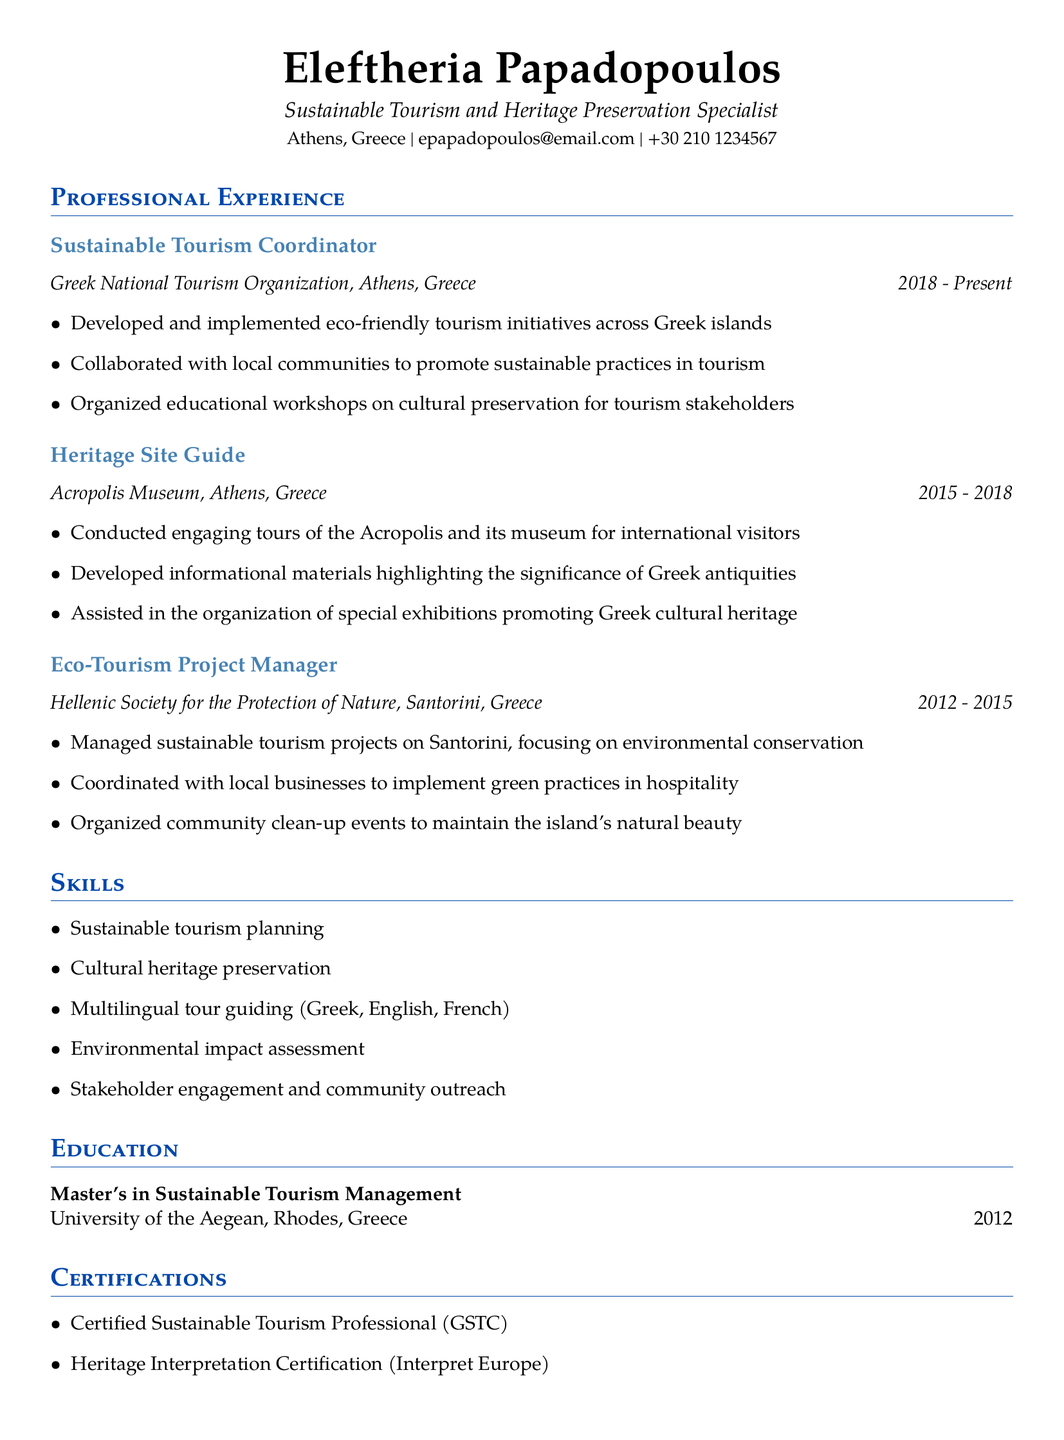what is the current position held by Eleftheria Papadopoulos? The document states that Eleftheria Papadopoulos is currently a Sustainable Tourism Coordinator.
Answer: Sustainable Tourism Coordinator what is the duration of Eleftheria's role at the Greek National Tourism Organization? The duration is specified as starting in 2018 and continuing to the present.
Answer: 2018 - Present how many languages can Eleftheria guide in? The document indicates that Eleftheria can guide in multiple languages, specifically mentioning three.
Answer: 3 what is the highest degree obtained by Eleftheria Papadopoulos? The document mentions that Eleftheria has a Master's in Sustainable Tourism Management.
Answer: Master's in Sustainable Tourism Management in which location did Eleftheria serve as an Eco-Tourism Project Manager? The document specifies that this role was held in Santorini, Greece.
Answer: Santorini, Greece what certification does Eleftheria have related to sustainable tourism? The document lists her as a Certified Sustainable Tourism Professional (GSTC).
Answer: Certified Sustainable Tourism Professional (GSTC) which organization did Eleftheria work for as a Heritage Site Guide? The document indicates that she worked at the Acropolis Museum.
Answer: Acropolis Museum what is one of the responsibilities of a Sustainable Tourism Coordinator? The responsibilities include developing and implementing eco-friendly tourism initiatives.
Answer: Developing and implementing eco-friendly tourism initiatives how long did Eleftheria work as a Heritage Site Guide? The duration of this role is noted from 2015 to 2018.
Answer: 2015 - 2018 what theme is central to Eleftheria's professional experience? The document emphasizes her focus on sustainable tourism and cultural heritage preservation.
Answer: Sustainable tourism and cultural heritage preservation 